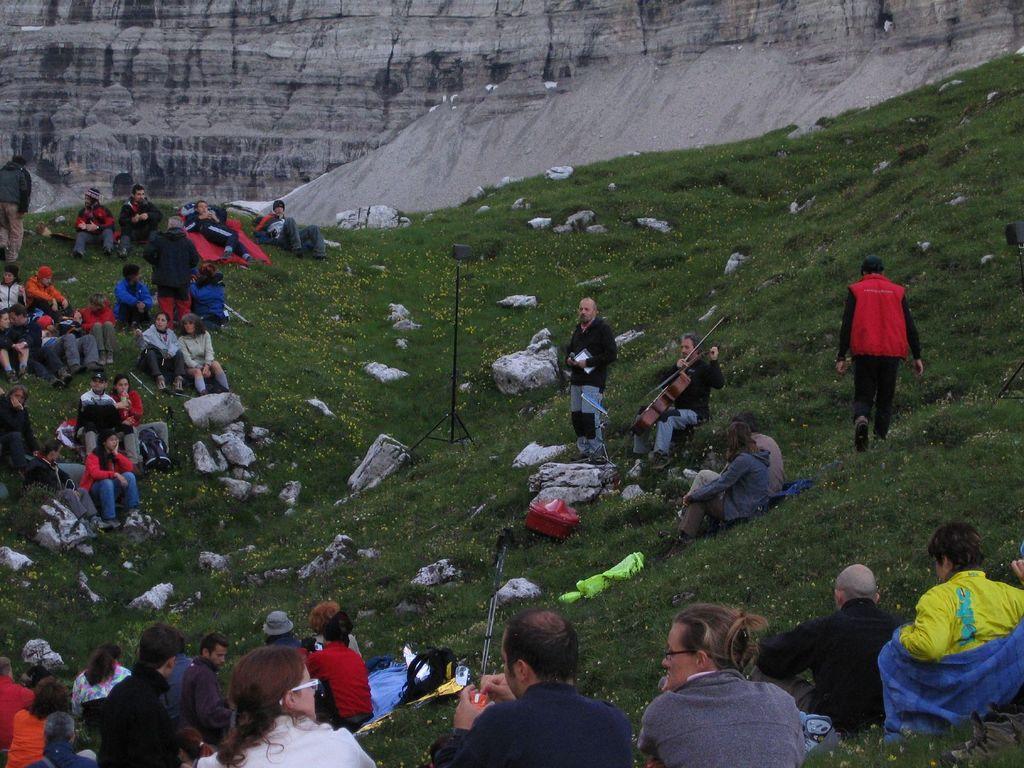Please provide a concise description of this image. In this picture we can see a group of people sitting, some people are standing, stand, bags, stones and some objects on the grass and a man holding a violin with his hands and in the background we can see the wall. 